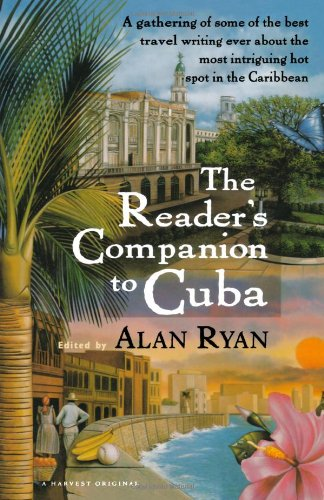Who wrote this book? The book 'The Reader's Companion to Cuba' was edited by Alan Ryan, as indicated by the text on its cover. 